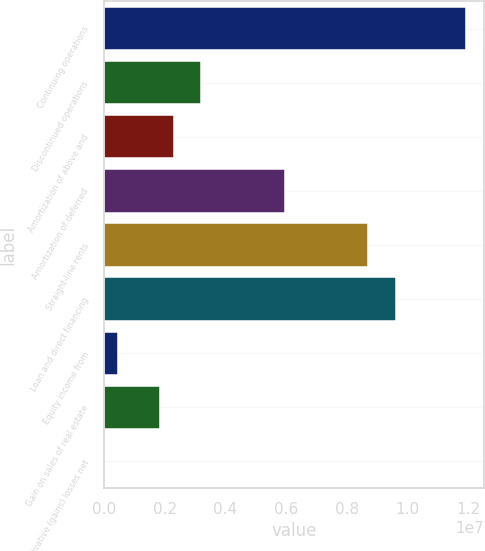Convert chart to OTSL. <chart><loc_0><loc_0><loc_500><loc_500><bar_chart><fcel>Continuing operations<fcel>Discontinued operations<fcel>Amortization of above and<fcel>Amortization of deferred<fcel>Straight-line rents<fcel>Loan and direct financing<fcel>Equity income from<fcel>Gain on sales of real estate<fcel>Derivative (gains) losses net<nl><fcel>1.19073e+07<fcel>3.20671e+06<fcel>2.29086e+06<fcel>5.95426e+06<fcel>8.70182e+06<fcel>9.61767e+06<fcel>459152<fcel>1.83293e+06<fcel>1226<nl></chart> 